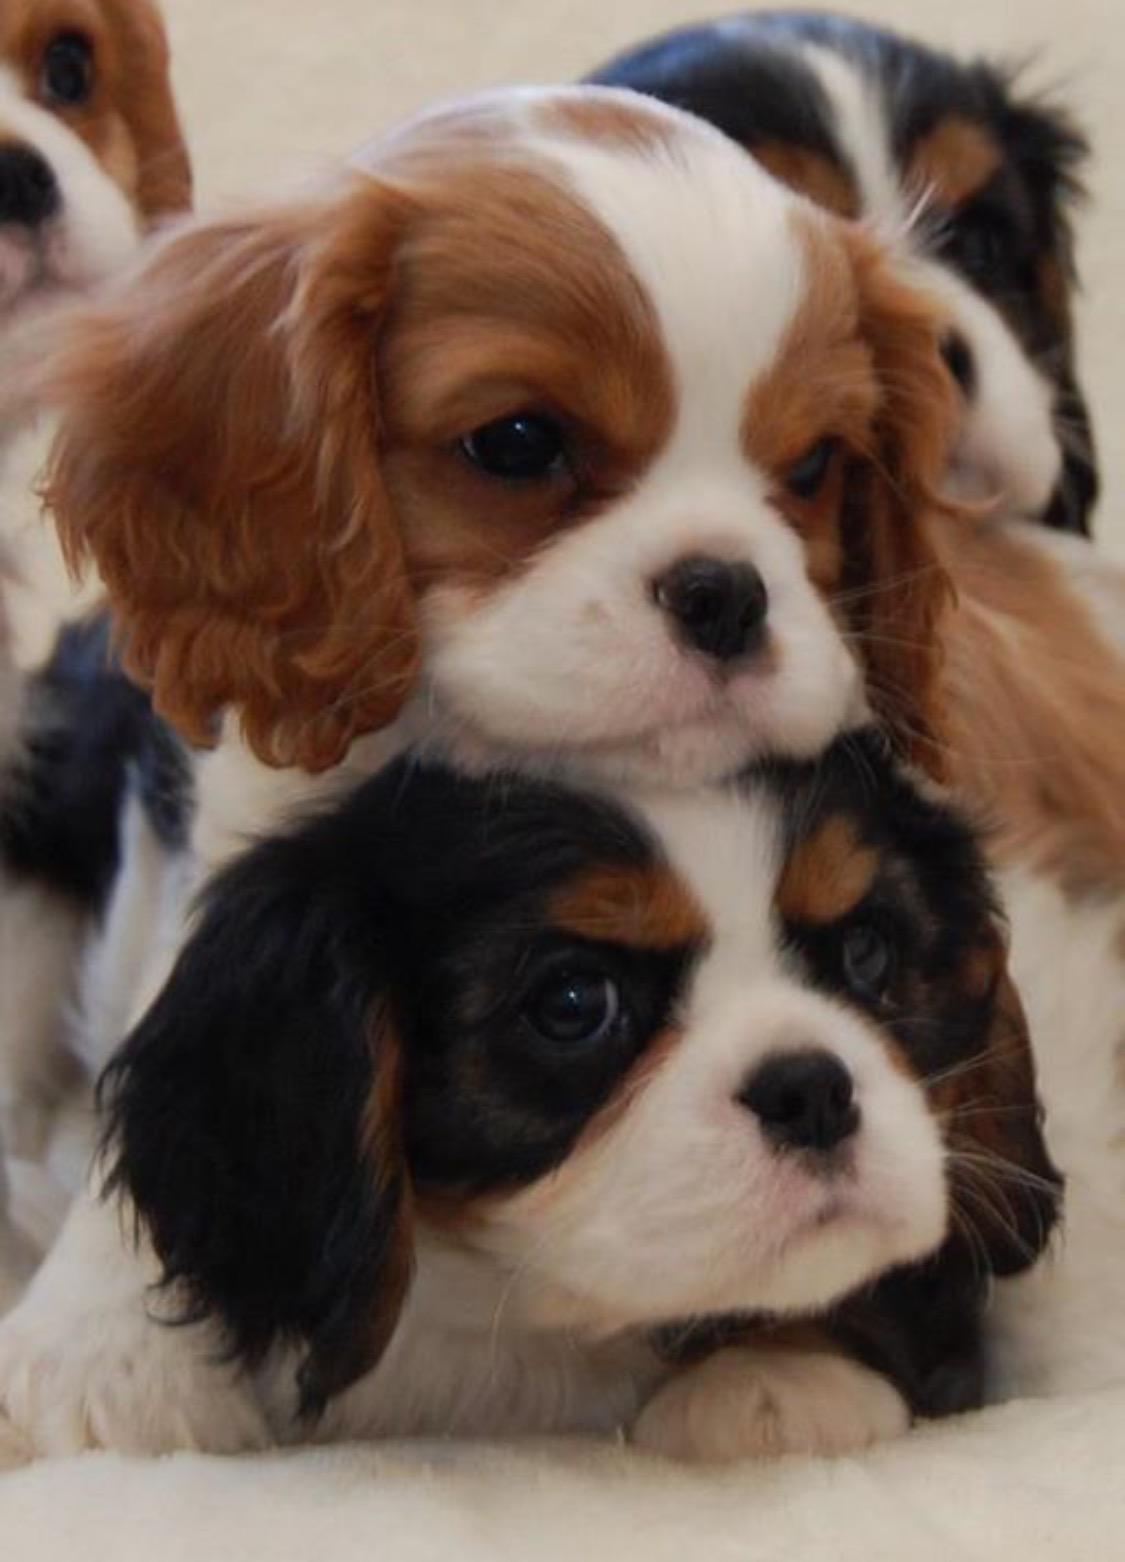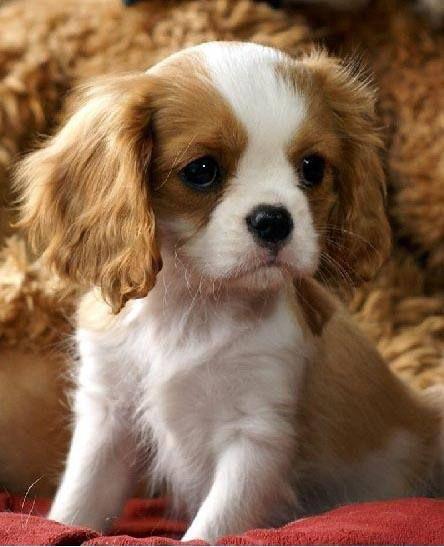The first image is the image on the left, the second image is the image on the right. Analyze the images presented: Is the assertion "There is a dog resting in the grass" valid? Answer yes or no. No. 